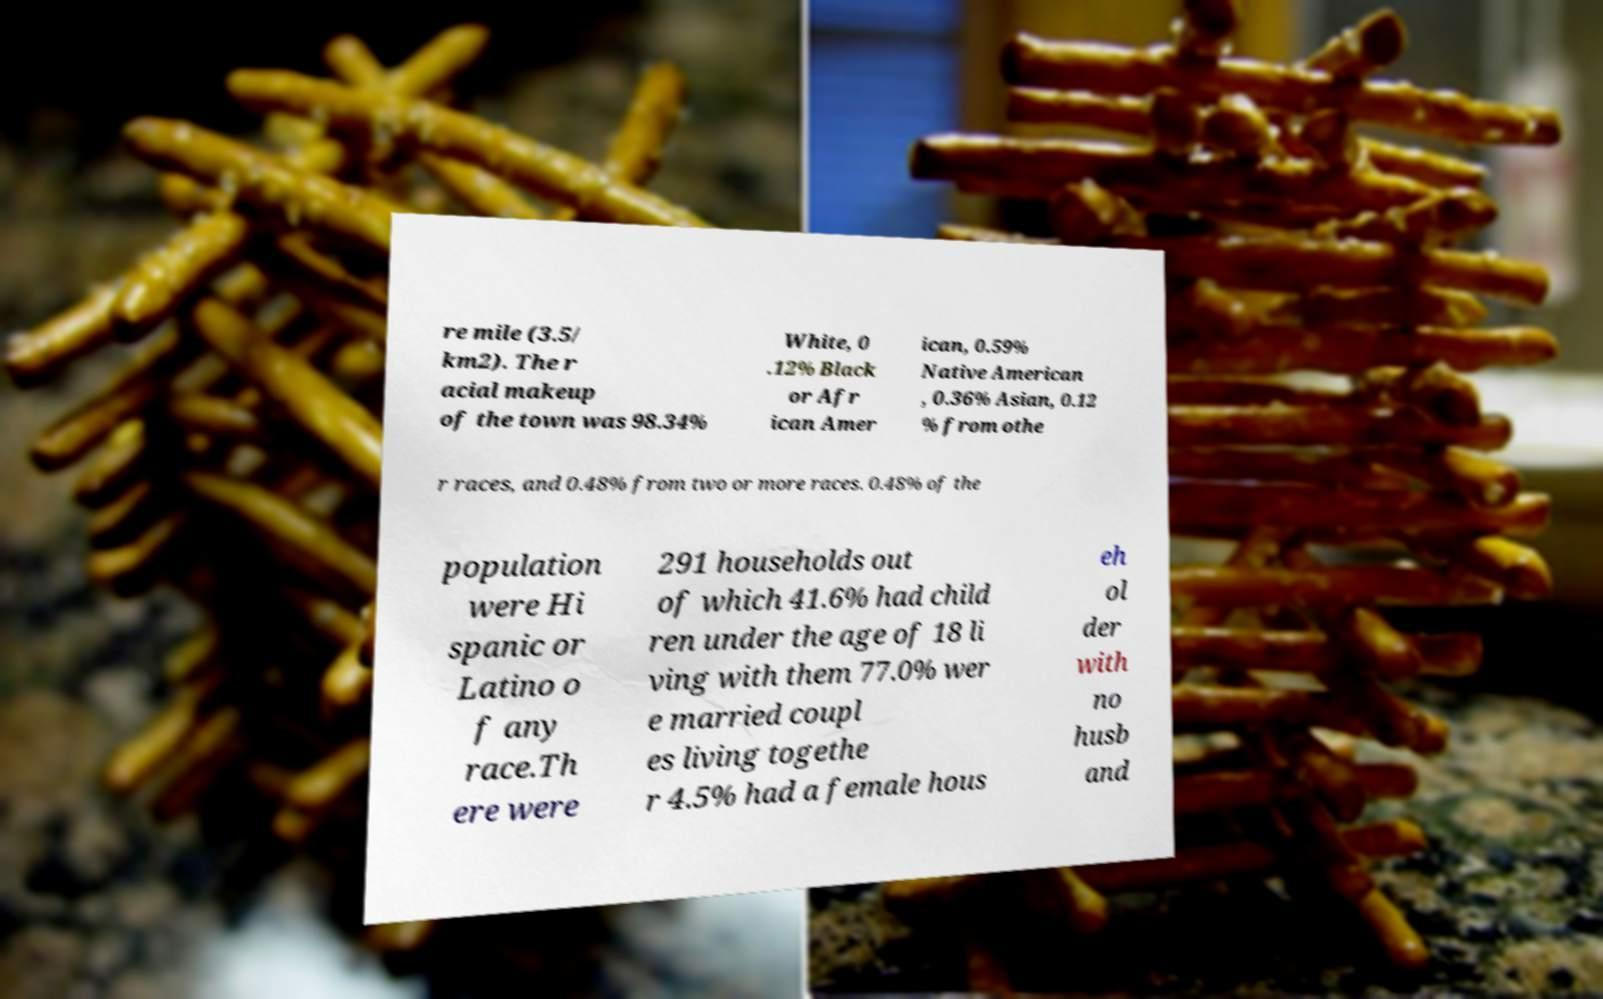Please read and relay the text visible in this image. What does it say? re mile (3.5/ km2). The r acial makeup of the town was 98.34% White, 0 .12% Black or Afr ican Amer ican, 0.59% Native American , 0.36% Asian, 0.12 % from othe r races, and 0.48% from two or more races. 0.48% of the population were Hi spanic or Latino o f any race.Th ere were 291 households out of which 41.6% had child ren under the age of 18 li ving with them 77.0% wer e married coupl es living togethe r 4.5% had a female hous eh ol der with no husb and 